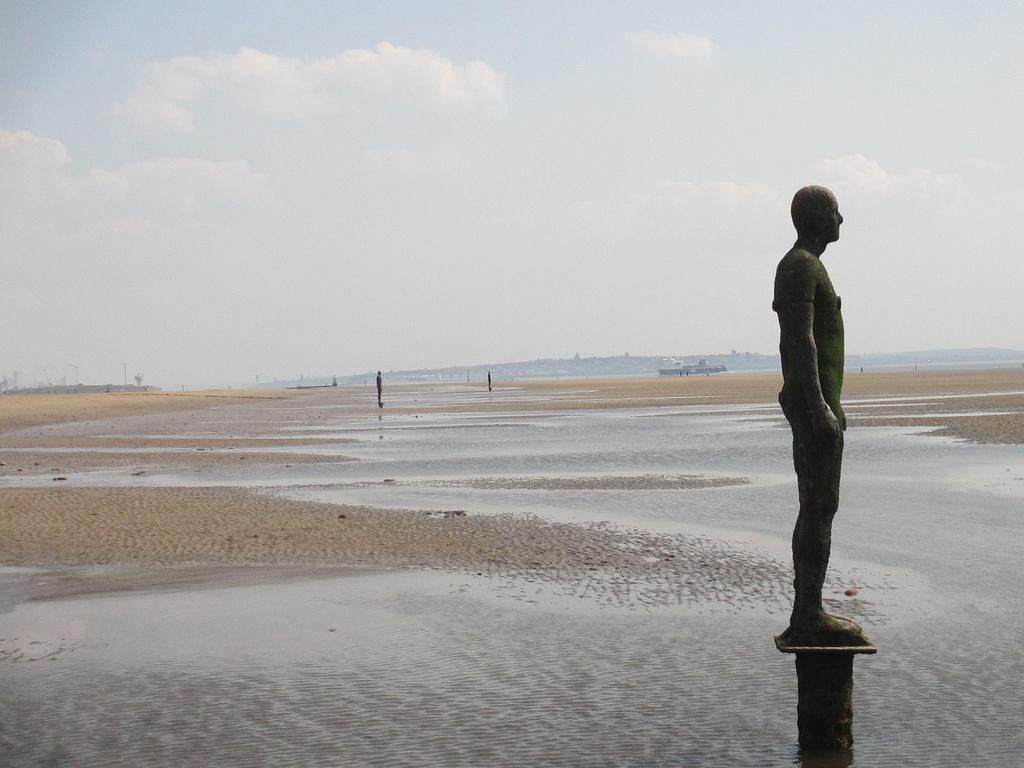Where was the image taken? The image was taken at a beach. What can be seen in the foreground of the image? There is sand, water, and a statue in the foreground of the image. What can be seen in the background of the image? There are statues, sand, people, a ship, and a hill in the background of the image. How is the sky depicted in the image? The sky is cloudy in the image. What type of steam is coming out of the ship in the image? There is no steam coming out of the ship in the image; it is not visible. What is the plot of the story unfolding in the image? The image does not depict a story or plot; it is a snapshot of a beach scene. 